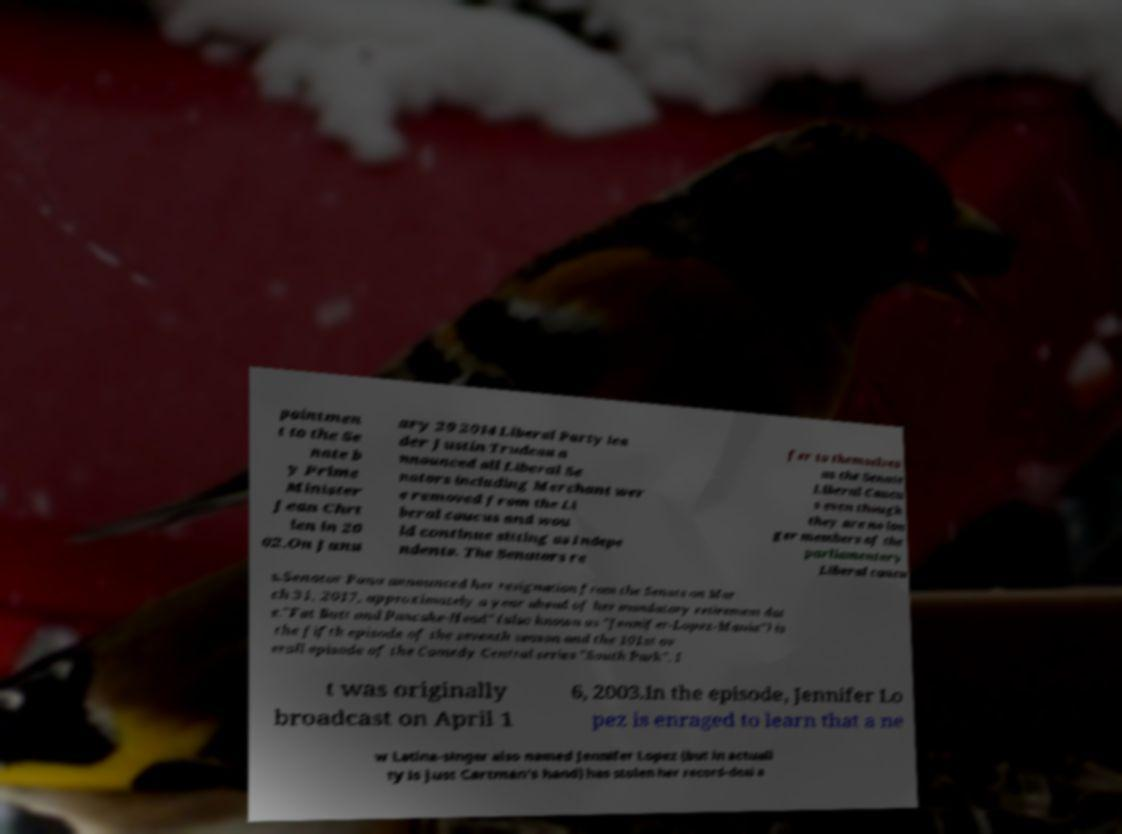Can you read and provide the text displayed in the image?This photo seems to have some interesting text. Can you extract and type it out for me? pointmen t to the Se nate b y Prime Minister Jean Chrt ien in 20 02.On Janu ary 29 2014 Liberal Party lea der Justin Trudeau a nnounced all Liberal Se nators including Merchant wer e removed from the Li beral caucus and wou ld continue sitting as Indepe ndents. The Senators re fer to themselves as the Senate Liberal Caucu s even though they are no lon ger members of the parliamentary Liberal caucu s.Senator Pana announced her resignation from the Senate on Mar ch 31, 2017, approximately a year ahead of her mandatory retirement dat e."Fat Butt and Pancake-Head" (also known as "Jennifer-Lopez-Mania") is the fifth episode of the seventh season and the 101st ov erall episode of the Comedy Central series "South Park". I t was originally broadcast on April 1 6, 2003.In the episode, Jennifer Lo pez is enraged to learn that a ne w Latina-singer also named Jennifer Lopez (but in actuali ty is just Cartman's hand) has stolen her record-deal a 